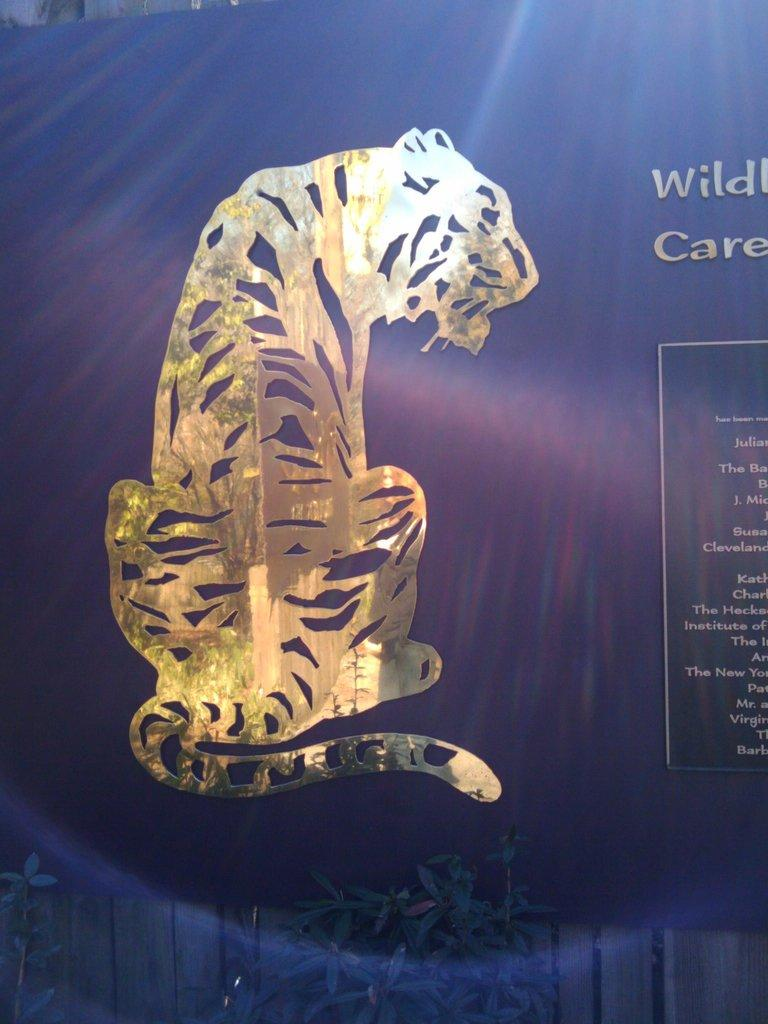What type of living organisms can be seen in the image? Plants are visible in the image. What color are the plants in the image? The plants are green in color. What else is present in the image besides the plants? There is a banner in the image. What color is the banner in the image? The banner is blue in color. What can be found on the banner? There is text written on the banner and a picture of an animal. What type of oil can be seen dripping from the plants in the image? There is no oil present in the image; the plants are green and not associated with any oil. 